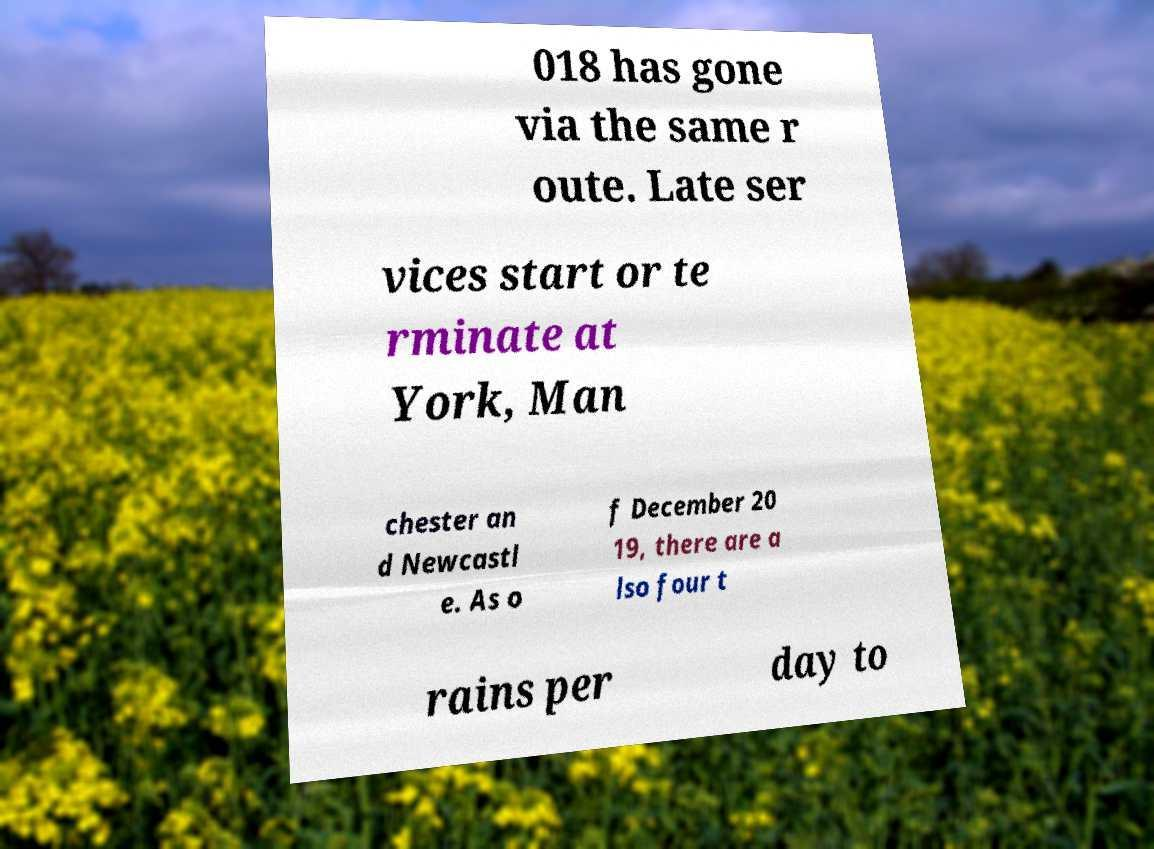Can you accurately transcribe the text from the provided image for me? 018 has gone via the same r oute. Late ser vices start or te rminate at York, Man chester an d Newcastl e. As o f December 20 19, there are a lso four t rains per day to 